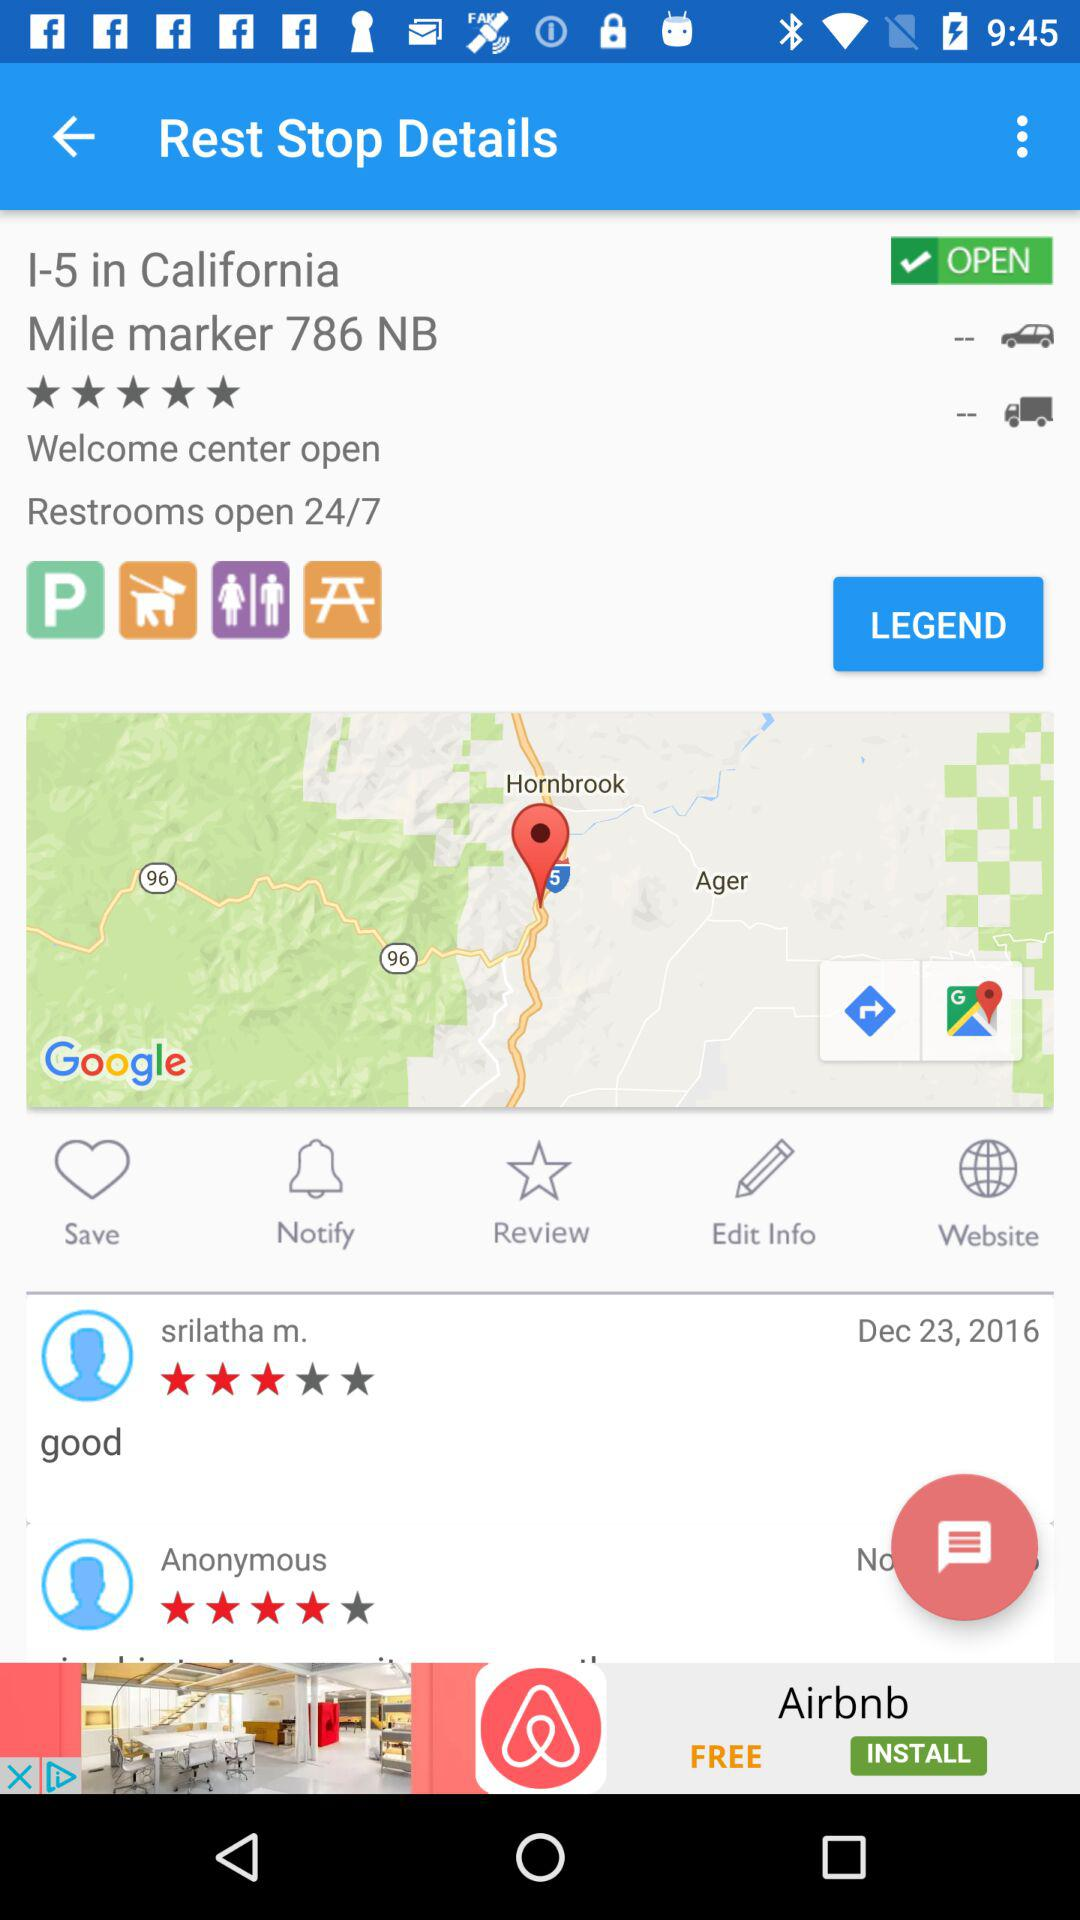What is the availability of restrooms? The availability of restrooms is 24/7. 